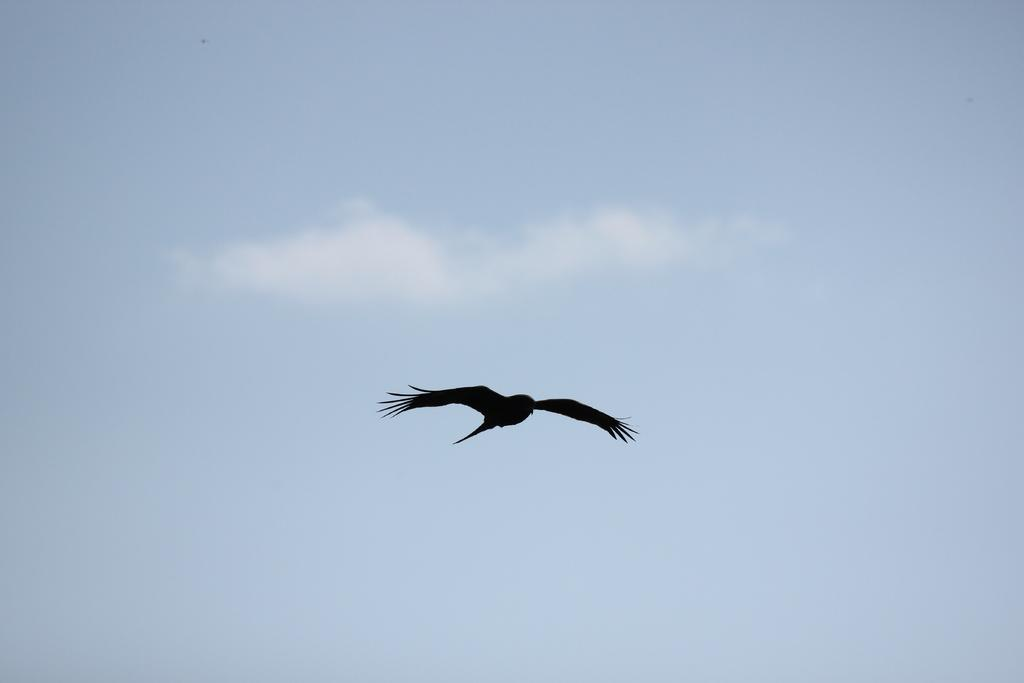What type of animal can be seen in the image? There is a bird in the image. Where is the bird located in the image? The bird is in the air. What can be seen in the background of the image? There is sky visible in the background of the image. What type of comb is the bird using to groom itself in the image? There is no comb present in the image, and the bird is not grooming itself. 